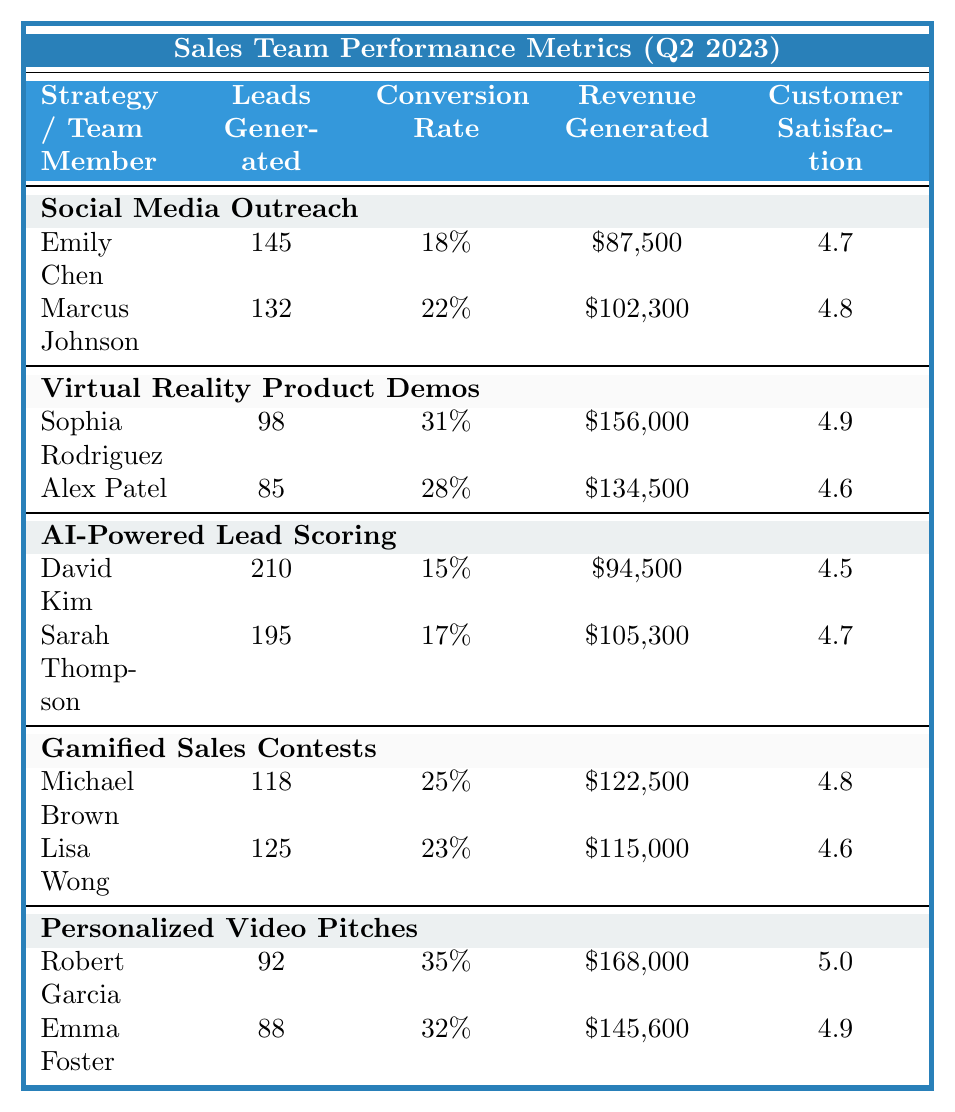What is the highest revenue generated by a team member using the Personalized Video Pitches strategy? Looking at the team members under the Personalized Video Pitches strategy, Robert Garcia generated $168,000, which is higher than Emma Foster’s $145,600. Thus, the highest revenue is from Robert Garcia.
Answer: $168,000 Which strategy had the highest average customer satisfaction score? The average customer satisfaction scores are calculated as follows: For Social Media Outreach, it’s (4.7 + 4.8)/2 = 4.75; for Virtual Reality Product Demos, it’s (4.9 + 4.6)/2 = 4.75; for AI-Powered Lead Scoring, it’s (4.5 + 4.7)/2 = 4.6; for Gamified Sales Contests, it’s (4.8 + 4.6)/2 = 4.7; and for Personalized Video Pitches, it’s (5.0 + 4.9)/2 = 4.95. The highest average customer satisfaction score is 4.95 for the Personalized Video Pitches strategy.
Answer: Personalized Video Pitches (4.95) How many leads were generated by the team members using Virtual Reality Product Demos? Adding the leads from both team members under this strategy gives us 98 (Sophia Rodriguez) + 85 (Alex Patel) = 183 leads generated in total.
Answer: 183 Which team member had the lowest conversion rate and what was that rate? Looking at the conversion rates, the lowest conversion rate is 15% from David Kim under the AI-Powered Lead Scoring strategy.
Answer: 15% What is the total revenue generated by team members using AI-Powered Lead Scoring? The total revenue generated is calculated by adding $94,500 (David Kim) and $105,300 (Sarah Thompson) which equals $199,800.
Answer: $199,800 Is there a team member who generated more than 200 leads, and if so, who are they? In the table, David Kim generated 210 leads, which is more than 200. Thus, he is the only one who meets this criterion.
Answer: Yes, David Kim Which strategy had the lowest average conversion rate? The average conversion rates are calculated as follows: Social Media Outreach = (18% + 22%)/2 = 20%; Virtual Reality Product Demos = (31% + 28%)/2 = 29.5%; AI-Powered Lead Scoring = (15% + 17%)/2 = 16%; Gamified Sales Contests = (25% + 23%)/2 = 24%; Personalized Video Pitches = (35% + 32%)/2 = 33.5%. The lowest average conversion rate is 16% for the AI-Powered Lead Scoring strategy.
Answer: AI-Powered Lead Scoring How much revenue did Marcus Johnson generate, and is it more than $100,000? Marcus Johnson generated $102,300, which is over $100,000. Thus, the answer confirms he indeed generated more than this amount.
Answer: Yes, $102,300 What is the difference in leads generated between the highest and lowest performing team members in terms of leads generated? The highest performing team member is David Kim with 210 leads, and the lowest is Alex Patel with 85 leads. The difference is 210 - 85 = 125.
Answer: 125 Are there any team members whose conversion rates are above 30%? Both Robert Garcia (35%) and Emma Foster (32%) under the Personalized Video Pitches strategy have conversion rates above 30%. Therefore, the answer is yes.
Answer: Yes, Robert Garcia and Emma Foster 